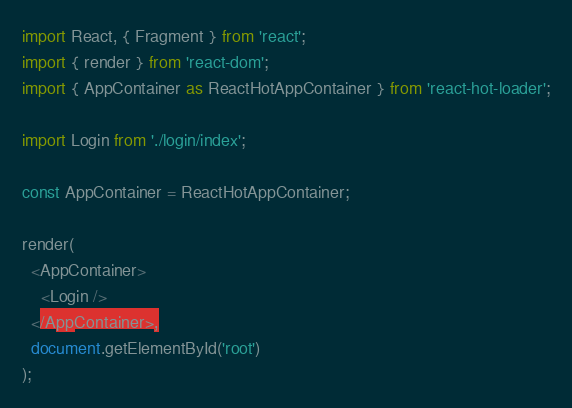Convert code to text. <code><loc_0><loc_0><loc_500><loc_500><_JavaScript_>import React, { Fragment } from 'react';
import { render } from 'react-dom';
import { AppContainer as ReactHotAppContainer } from 'react-hot-loader';

import Login from './login/index';

const AppContainer = ReactHotAppContainer;

render(
  <AppContainer>
    <Login />
  </AppContainer>,
  document.getElementById('root')
);
</code> 